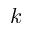Convert formula to latex. <formula><loc_0><loc_0><loc_500><loc_500>k</formula> 